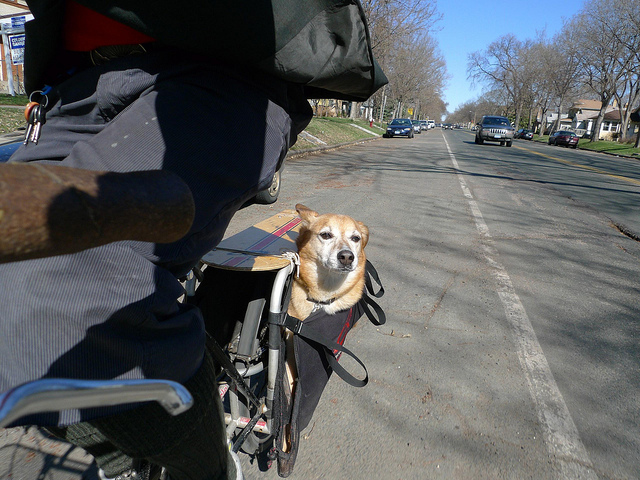Where does this scene seem to be taking place? The scene appears to be unfolding on a sunny day along a suburban street, indicated by the residential houses, parked cars, and the clear presence of a roadway suitable for biking. 